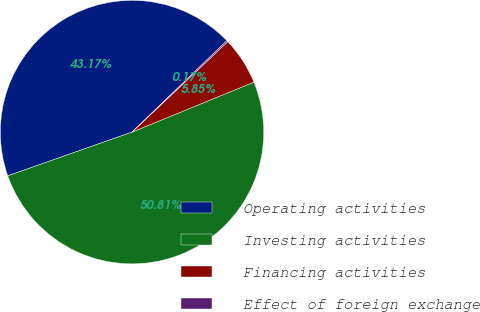Convert chart. <chart><loc_0><loc_0><loc_500><loc_500><pie_chart><fcel>Operating activities<fcel>Investing activities<fcel>Financing activities<fcel>Effect of foreign exchange<nl><fcel>43.17%<fcel>50.81%<fcel>5.85%<fcel>0.17%<nl></chart> 